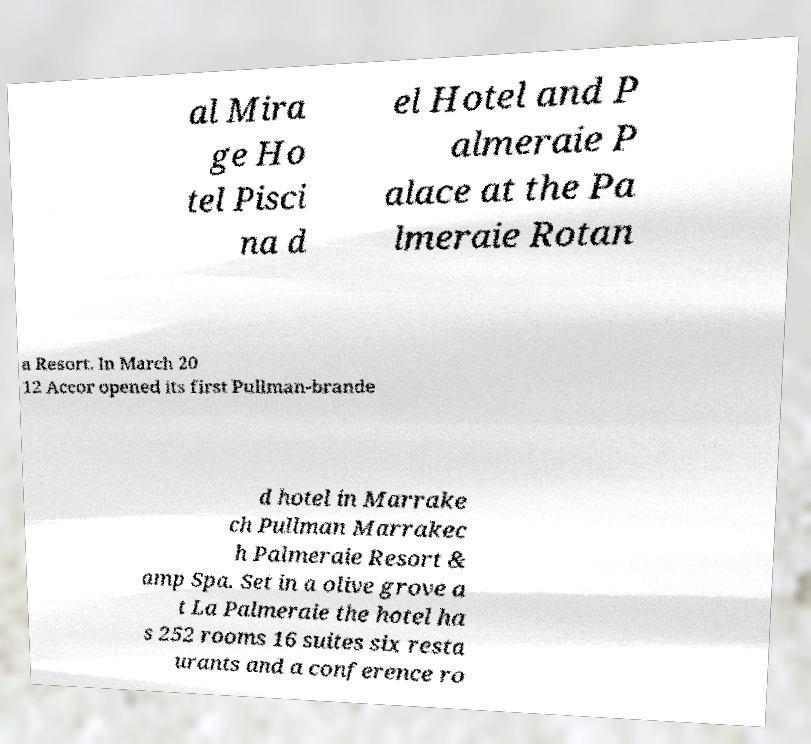Could you extract and type out the text from this image? al Mira ge Ho tel Pisci na d el Hotel and P almeraie P alace at the Pa lmeraie Rotan a Resort. In March 20 12 Accor opened its first Pullman-brande d hotel in Marrake ch Pullman Marrakec h Palmeraie Resort & amp Spa. Set in a olive grove a t La Palmeraie the hotel ha s 252 rooms 16 suites six resta urants and a conference ro 